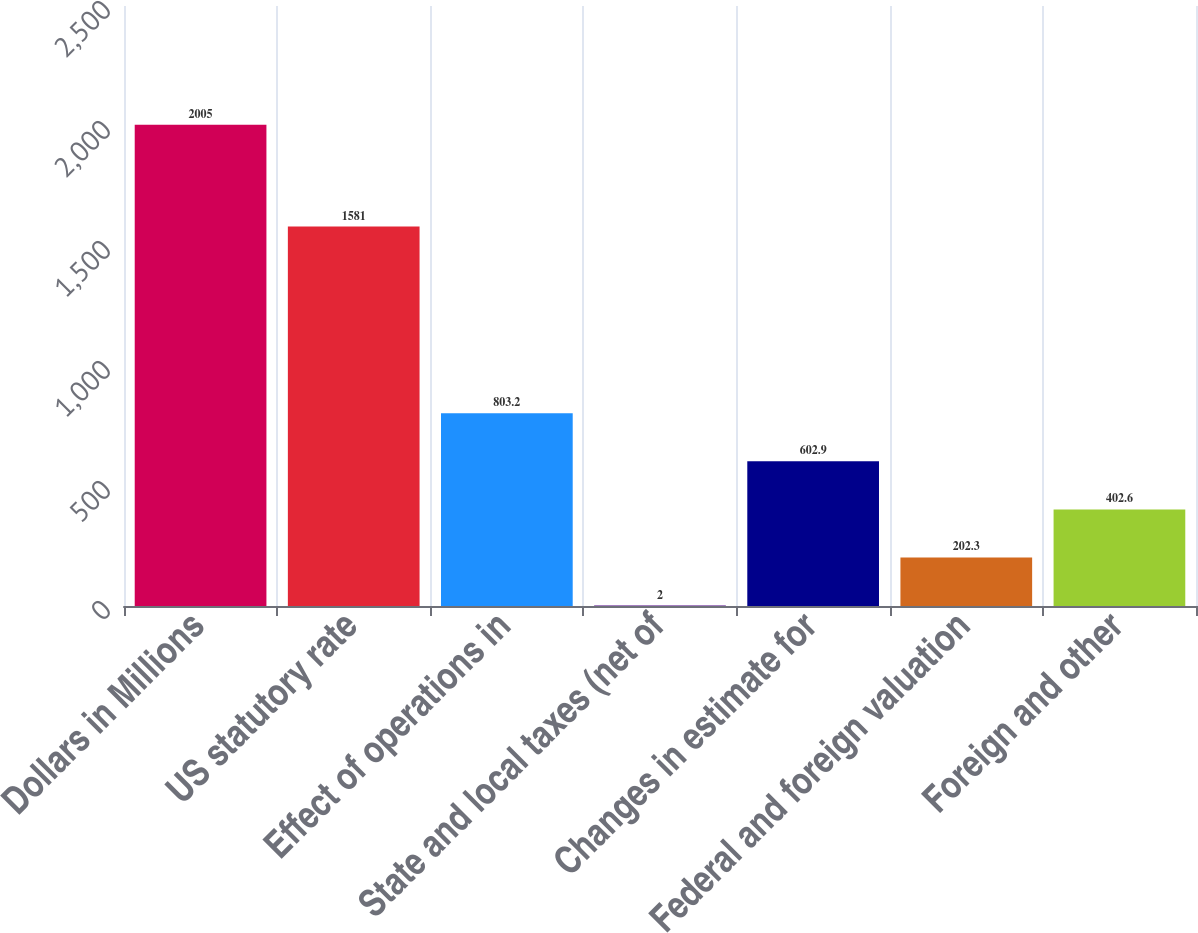<chart> <loc_0><loc_0><loc_500><loc_500><bar_chart><fcel>Dollars in Millions<fcel>US statutory rate<fcel>Effect of operations in<fcel>State and local taxes (net of<fcel>Changes in estimate for<fcel>Federal and foreign valuation<fcel>Foreign and other<nl><fcel>2005<fcel>1581<fcel>803.2<fcel>2<fcel>602.9<fcel>202.3<fcel>402.6<nl></chart> 